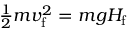<formula> <loc_0><loc_0><loc_500><loc_500>\frac { 1 } { 2 } m v _ { f } ^ { 2 } = m g H _ { f }</formula> 